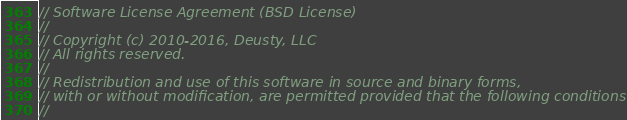<code> <loc_0><loc_0><loc_500><loc_500><_C_>// Software License Agreement (BSD License)
//
// Copyright (c) 2010-2016, Deusty, LLC
// All rights reserved.
//
// Redistribution and use of this software in source and binary forms,
// with or without modification, are permitted provided that the following conditions are met:
//</code> 